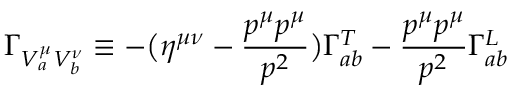Convert formula to latex. <formula><loc_0><loc_0><loc_500><loc_500>\Gamma _ { V _ { a } ^ { \mu } V _ { b } ^ { \nu } } \equiv - \left ( \eta ^ { \mu \nu } - { \frac { p ^ { \mu } p ^ { \mu } } { p ^ { 2 } } } \right ) \Gamma _ { a b } ^ { T } - { \frac { p ^ { \mu } p ^ { \mu } } { p ^ { 2 } } } \Gamma _ { a b } ^ { L }</formula> 